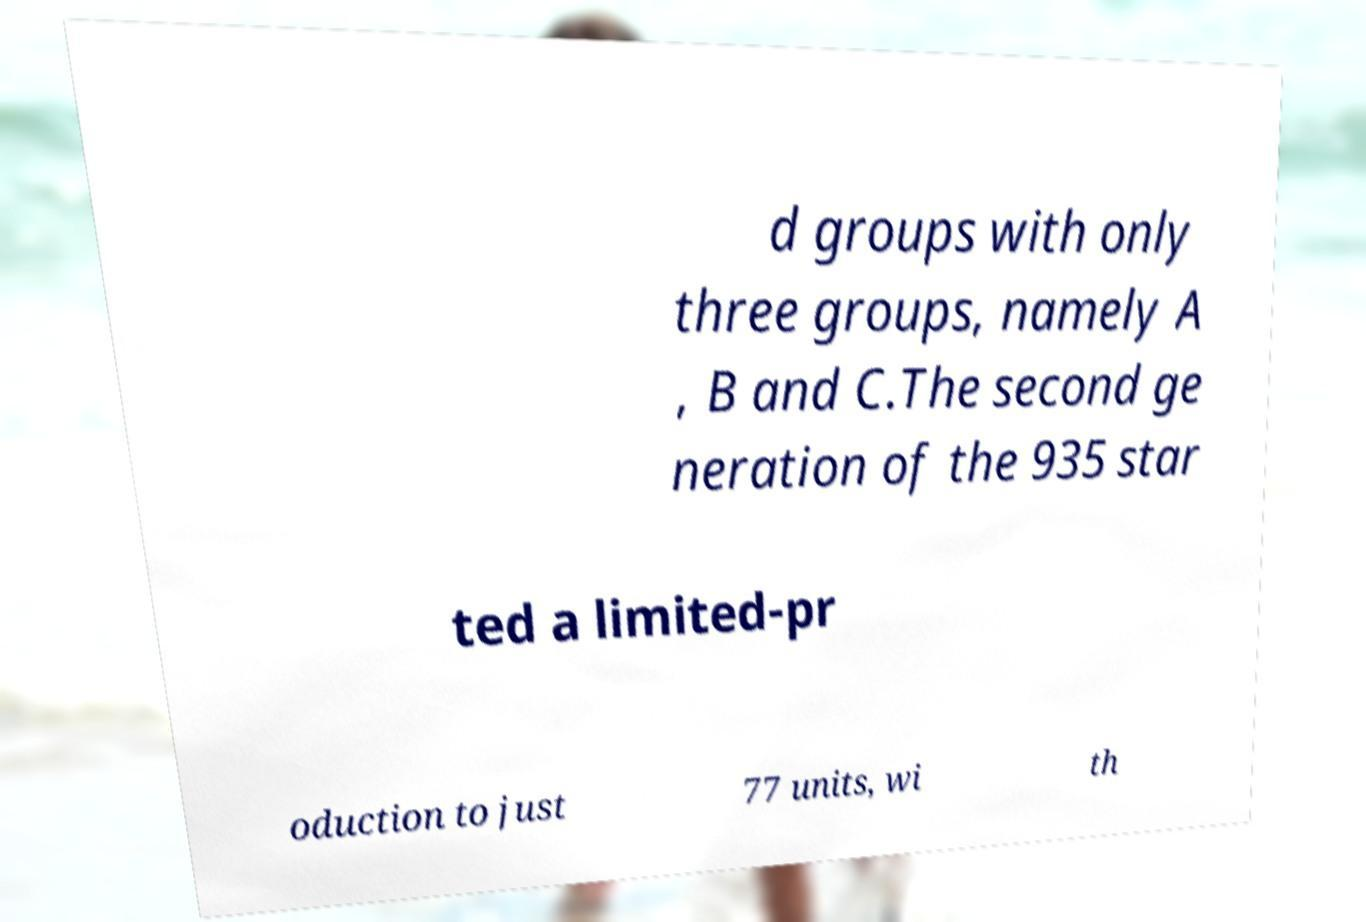Please identify and transcribe the text found in this image. d groups with only three groups, namely A , B and C.The second ge neration of the 935 star ted a limited-pr oduction to just 77 units, wi th 